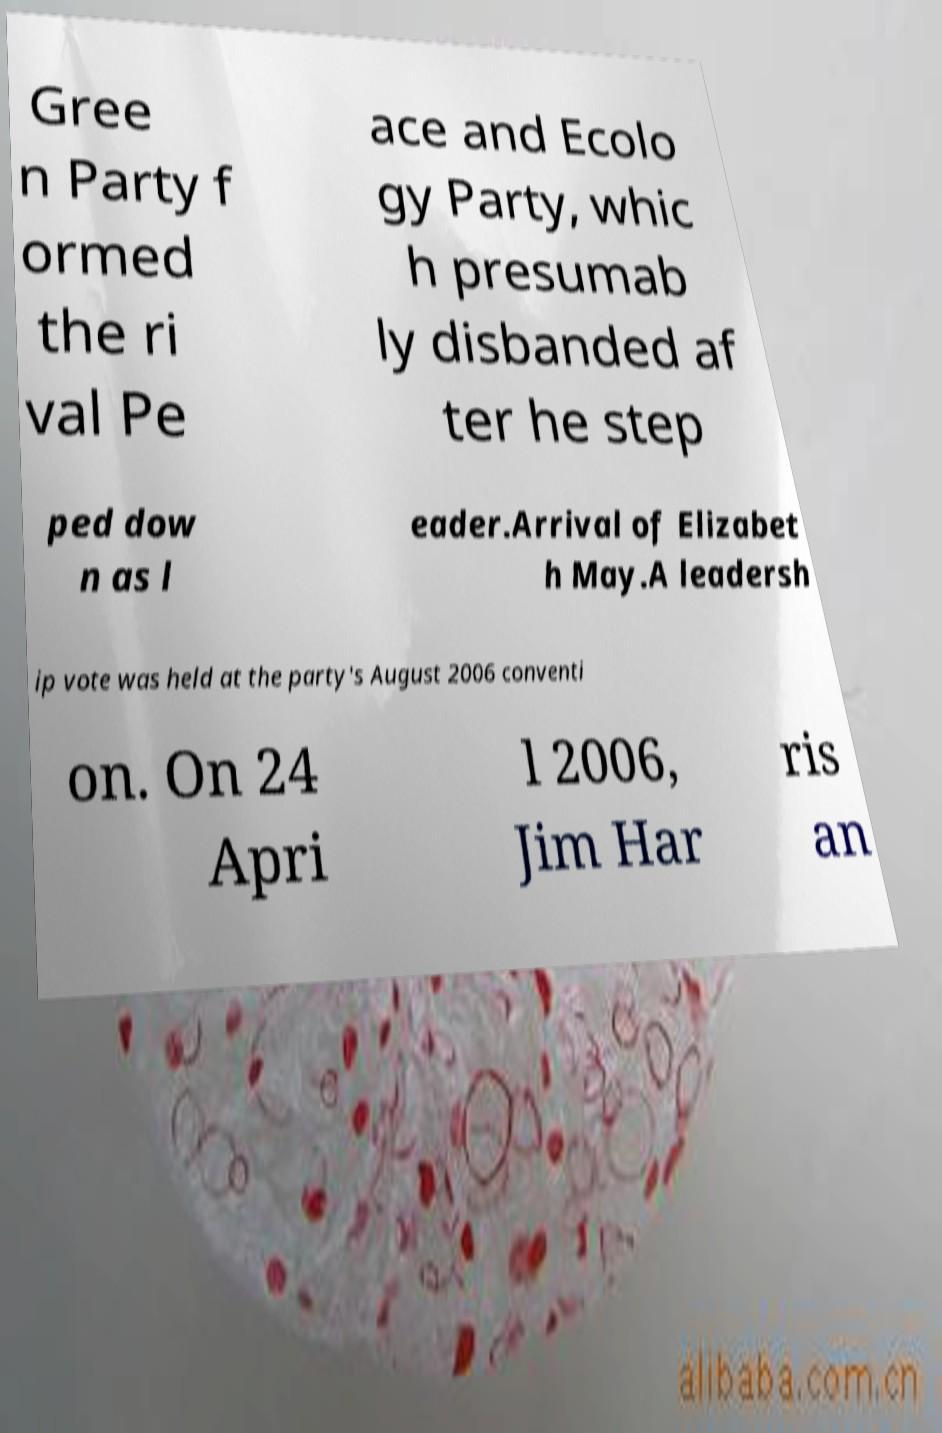Please read and relay the text visible in this image. What does it say? Gree n Party f ormed the ri val Pe ace and Ecolo gy Party, whic h presumab ly disbanded af ter he step ped dow n as l eader.Arrival of Elizabet h May.A leadersh ip vote was held at the party's August 2006 conventi on. On 24 Apri l 2006, Jim Har ris an 